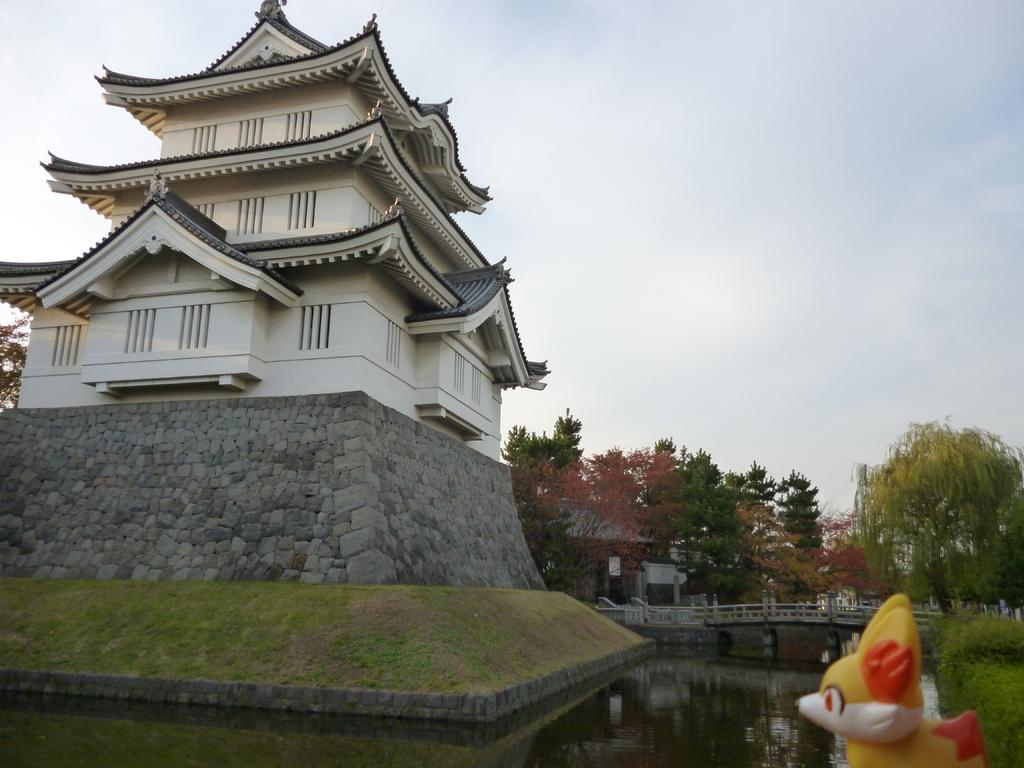What type of structure is present in the image? There is a building in the image. What other natural elements can be seen in the image? There are trees and water visible in the image. What additional object is present in the image? There is a doll in the image. How can one cross the water in the image? There is a bridge in the image that can be used to cross the water. What is visible in the background of the image? The sky is visible in the background of the image. What type of straw is being used by the man in the image? There is no man present in the image, and therefore no straw can be observed. 